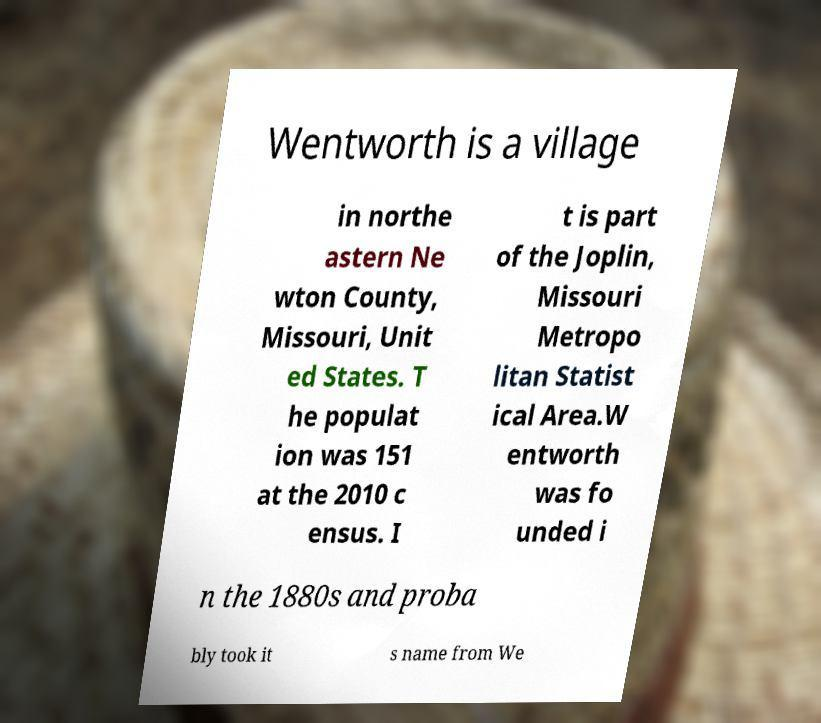I need the written content from this picture converted into text. Can you do that? Wentworth is a village in northe astern Ne wton County, Missouri, Unit ed States. T he populat ion was 151 at the 2010 c ensus. I t is part of the Joplin, Missouri Metropo litan Statist ical Area.W entworth was fo unded i n the 1880s and proba bly took it s name from We 